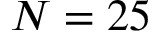<formula> <loc_0><loc_0><loc_500><loc_500>N = 2 5</formula> 